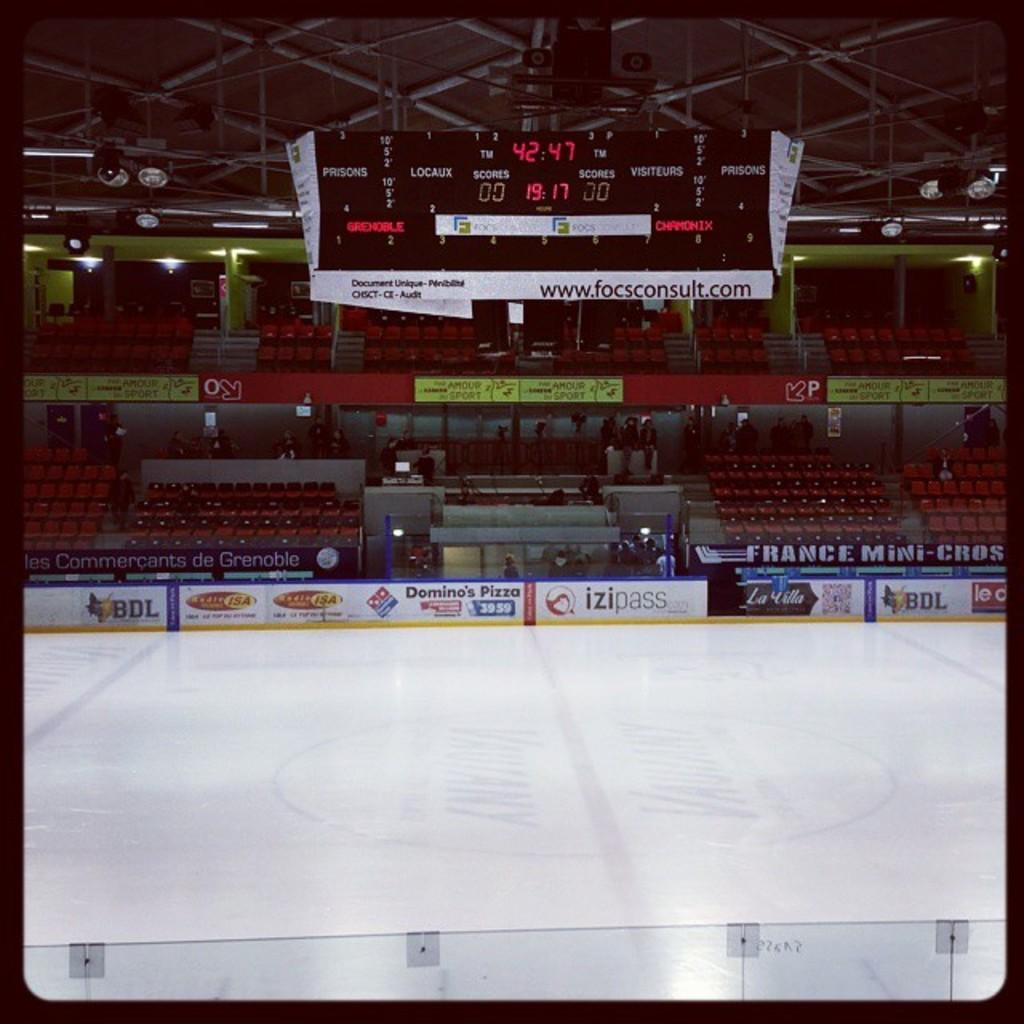<image>
Describe the image concisely. An empty ice hockey rink with a scoreboard showing a score of 0 to 0. 